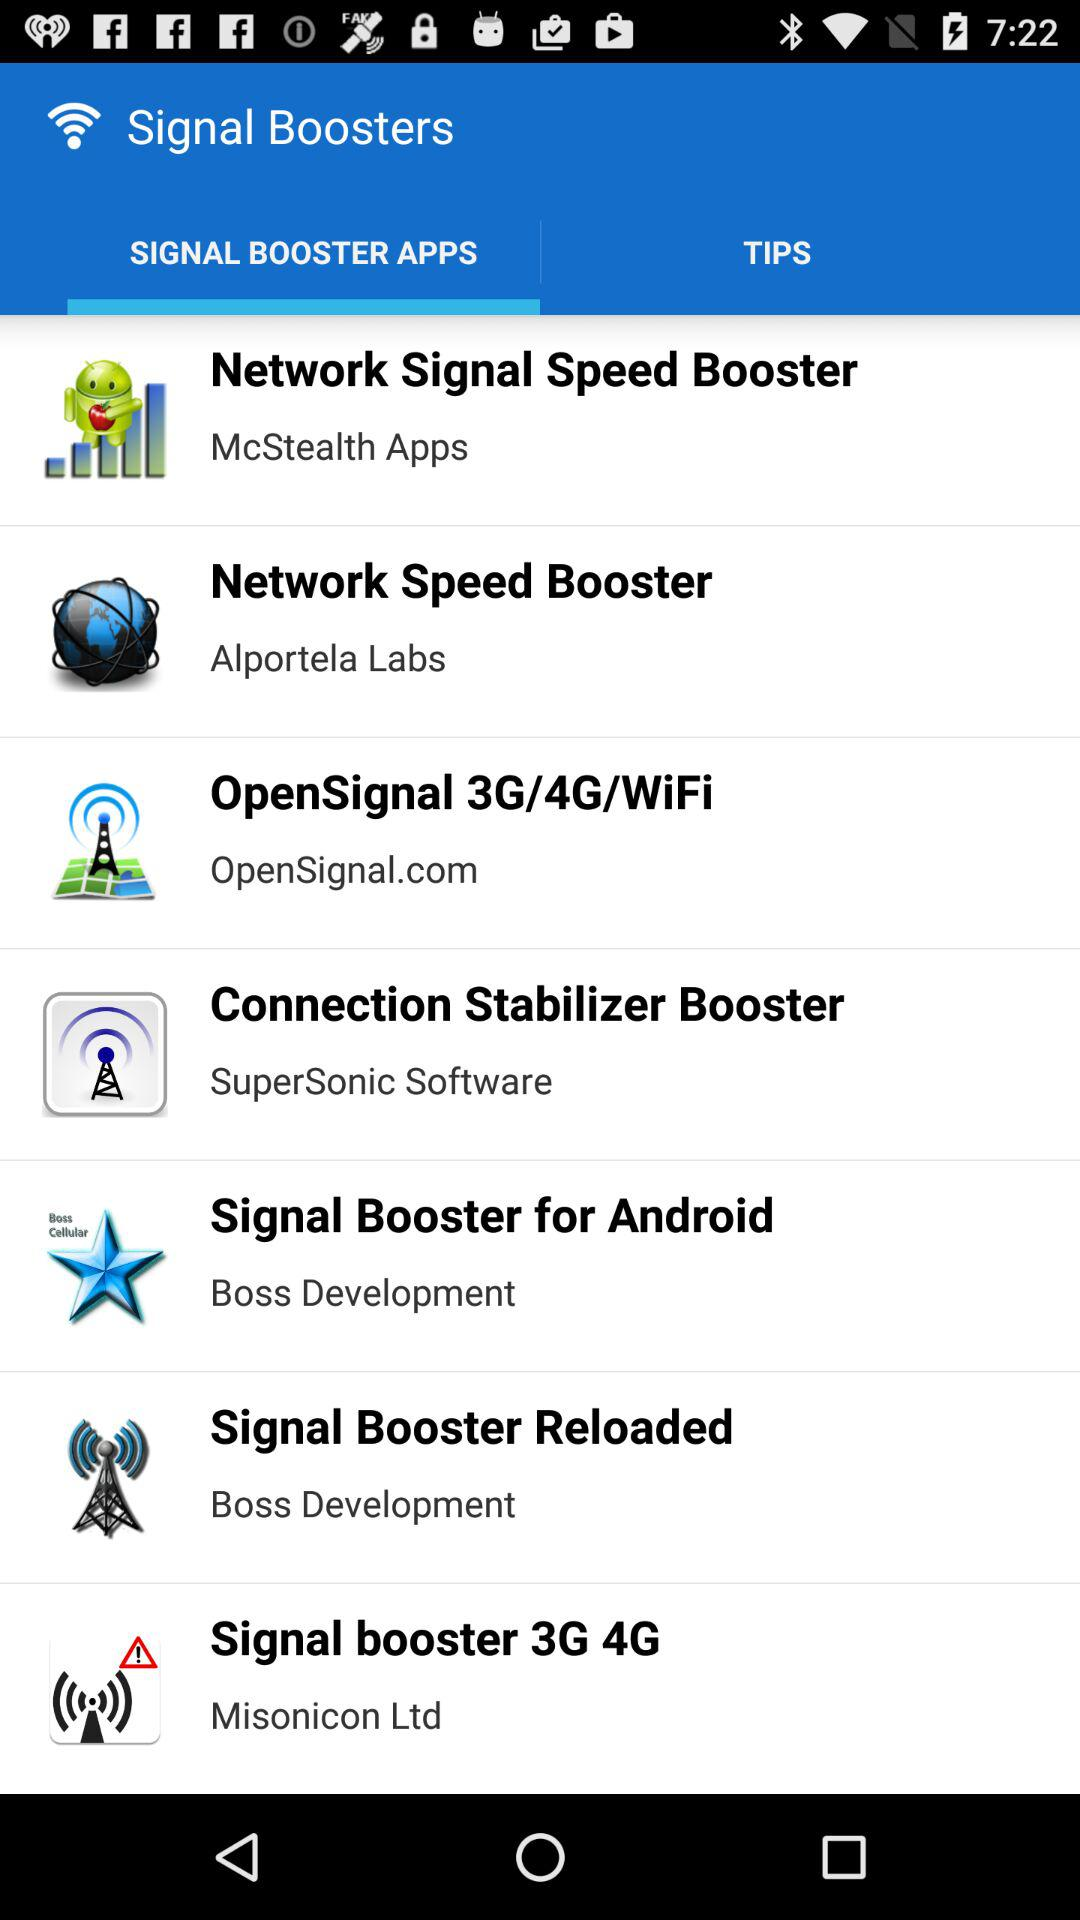Which tab is selected? The selected tab is "SIGNAL BOOSTER APPS". 